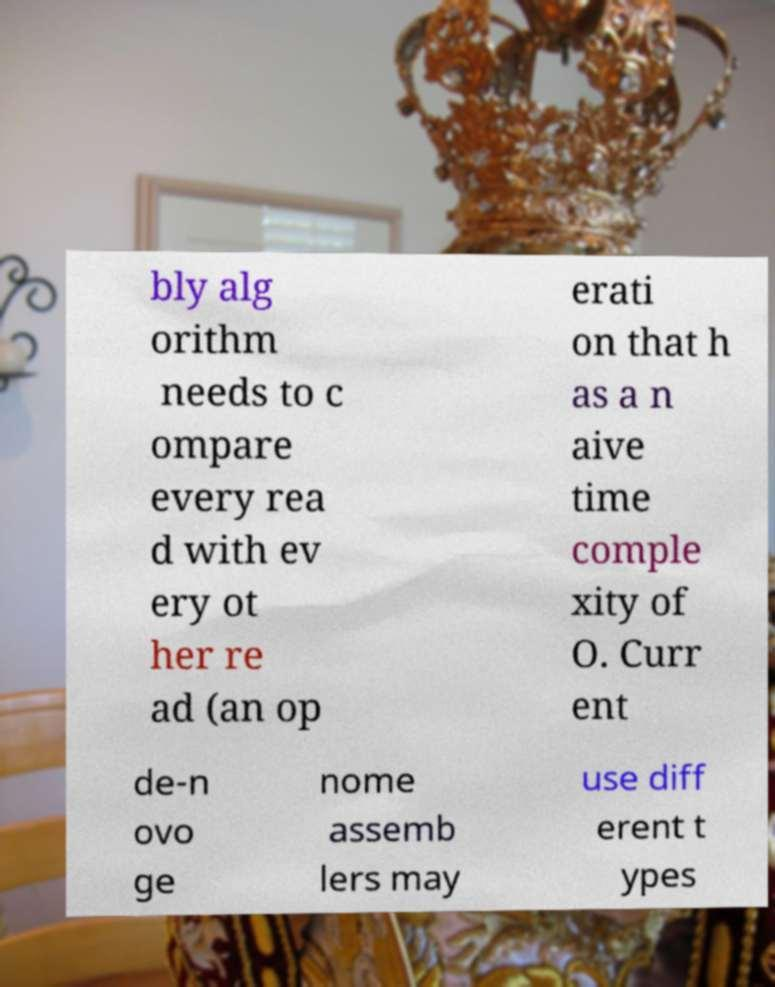For documentation purposes, I need the text within this image transcribed. Could you provide that? bly alg orithm needs to c ompare every rea d with ev ery ot her re ad (an op erati on that h as a n aive time comple xity of O. Curr ent de-n ovo ge nome assemb lers may use diff erent t ypes 